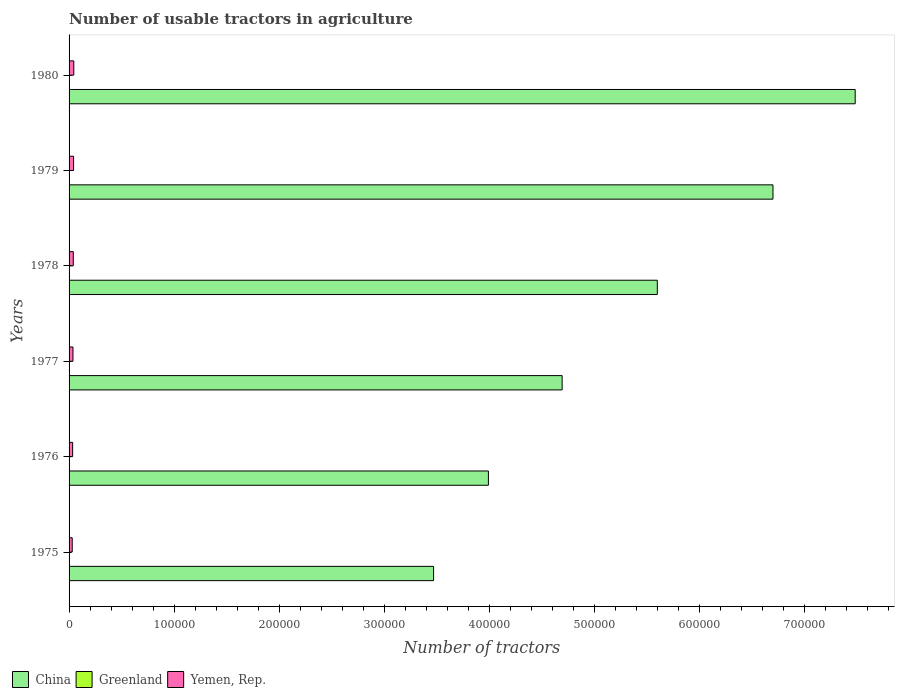How many different coloured bars are there?
Your answer should be very brief. 3. How many groups of bars are there?
Your answer should be compact. 6. How many bars are there on the 5th tick from the top?
Give a very brief answer. 3. What is the label of the 2nd group of bars from the top?
Your response must be concise. 1979. In how many cases, is the number of bars for a given year not equal to the number of legend labels?
Offer a terse response. 0. What is the number of usable tractors in agriculture in Greenland in 1980?
Your answer should be compact. 76. Across all years, what is the maximum number of usable tractors in agriculture in China?
Offer a terse response. 7.48e+05. Across all years, what is the minimum number of usable tractors in agriculture in China?
Make the answer very short. 3.47e+05. In which year was the number of usable tractors in agriculture in Yemen, Rep. maximum?
Your answer should be very brief. 1980. In which year was the number of usable tractors in agriculture in Greenland minimum?
Make the answer very short. 1975. What is the total number of usable tractors in agriculture in Yemen, Rep. in the graph?
Make the answer very short. 2.29e+04. What is the difference between the number of usable tractors in agriculture in Yemen, Rep. in 1975 and that in 1977?
Ensure brevity in your answer.  -700. What is the difference between the number of usable tractors in agriculture in Greenland in 1979 and the number of usable tractors in agriculture in Yemen, Rep. in 1977?
Give a very brief answer. -3626. In the year 1978, what is the difference between the number of usable tractors in agriculture in China and number of usable tractors in agriculture in Greenland?
Keep it short and to the point. 5.60e+05. In how many years, is the number of usable tractors in agriculture in Yemen, Rep. greater than 500000 ?
Offer a terse response. 0. What is the ratio of the number of usable tractors in agriculture in Greenland in 1975 to that in 1977?
Keep it short and to the point. 0.94. Is the difference between the number of usable tractors in agriculture in China in 1975 and 1976 greater than the difference between the number of usable tractors in agriculture in Greenland in 1975 and 1976?
Offer a very short reply. No. What is the difference between the highest and the lowest number of usable tractors in agriculture in China?
Your response must be concise. 4.01e+05. In how many years, is the number of usable tractors in agriculture in Greenland greater than the average number of usable tractors in agriculture in Greenland taken over all years?
Your response must be concise. 3. Is the sum of the number of usable tractors in agriculture in Greenland in 1975 and 1976 greater than the maximum number of usable tractors in agriculture in China across all years?
Provide a short and direct response. No. What does the 2nd bar from the top in 1978 represents?
Provide a succinct answer. Greenland. What does the 1st bar from the bottom in 1978 represents?
Your response must be concise. China. Is it the case that in every year, the sum of the number of usable tractors in agriculture in China and number of usable tractors in agriculture in Greenland is greater than the number of usable tractors in agriculture in Yemen, Rep.?
Your answer should be very brief. Yes. How many bars are there?
Provide a short and direct response. 18. Are all the bars in the graph horizontal?
Give a very brief answer. Yes. Are the values on the major ticks of X-axis written in scientific E-notation?
Your response must be concise. No. Does the graph contain any zero values?
Your response must be concise. No. Where does the legend appear in the graph?
Keep it short and to the point. Bottom left. What is the title of the graph?
Ensure brevity in your answer.  Number of usable tractors in agriculture. What is the label or title of the X-axis?
Provide a short and direct response. Number of tractors. What is the Number of tractors in China in 1975?
Your answer should be very brief. 3.47e+05. What is the Number of tractors of Greenland in 1975?
Offer a terse response. 66. What is the Number of tractors in Yemen, Rep. in 1975?
Ensure brevity in your answer.  3000. What is the Number of tractors of China in 1976?
Your answer should be compact. 3.99e+05. What is the Number of tractors of Greenland in 1976?
Provide a succinct answer. 68. What is the Number of tractors of Yemen, Rep. in 1976?
Your answer should be very brief. 3400. What is the Number of tractors in China in 1977?
Make the answer very short. 4.69e+05. What is the Number of tractors of Yemen, Rep. in 1977?
Keep it short and to the point. 3700. What is the Number of tractors of China in 1978?
Provide a succinct answer. 5.60e+05. What is the Number of tractors in Yemen, Rep. in 1978?
Provide a short and direct response. 4000. What is the Number of tractors in China in 1979?
Your response must be concise. 6.70e+05. What is the Number of tractors in Greenland in 1979?
Your response must be concise. 74. What is the Number of tractors in Yemen, Rep. in 1979?
Give a very brief answer. 4300. What is the Number of tractors of China in 1980?
Keep it short and to the point. 7.48e+05. What is the Number of tractors of Greenland in 1980?
Your answer should be very brief. 76. What is the Number of tractors of Yemen, Rep. in 1980?
Provide a succinct answer. 4500. Across all years, what is the maximum Number of tractors in China?
Ensure brevity in your answer.  7.48e+05. Across all years, what is the maximum Number of tractors in Greenland?
Provide a short and direct response. 76. Across all years, what is the maximum Number of tractors in Yemen, Rep.?
Offer a terse response. 4500. Across all years, what is the minimum Number of tractors in China?
Keep it short and to the point. 3.47e+05. Across all years, what is the minimum Number of tractors of Greenland?
Offer a very short reply. 66. Across all years, what is the minimum Number of tractors of Yemen, Rep.?
Make the answer very short. 3000. What is the total Number of tractors of China in the graph?
Offer a terse response. 3.19e+06. What is the total Number of tractors of Greenland in the graph?
Your response must be concise. 426. What is the total Number of tractors of Yemen, Rep. in the graph?
Your answer should be compact. 2.29e+04. What is the difference between the Number of tractors in China in 1975 and that in 1976?
Keep it short and to the point. -5.22e+04. What is the difference between the Number of tractors of Greenland in 1975 and that in 1976?
Provide a short and direct response. -2. What is the difference between the Number of tractors of Yemen, Rep. in 1975 and that in 1976?
Your answer should be compact. -400. What is the difference between the Number of tractors of China in 1975 and that in 1977?
Offer a very short reply. -1.22e+05. What is the difference between the Number of tractors of Greenland in 1975 and that in 1977?
Your response must be concise. -4. What is the difference between the Number of tractors in Yemen, Rep. in 1975 and that in 1977?
Provide a succinct answer. -700. What is the difference between the Number of tractors in China in 1975 and that in 1978?
Offer a very short reply. -2.13e+05. What is the difference between the Number of tractors of Greenland in 1975 and that in 1978?
Your answer should be very brief. -6. What is the difference between the Number of tractors of Yemen, Rep. in 1975 and that in 1978?
Ensure brevity in your answer.  -1000. What is the difference between the Number of tractors of China in 1975 and that in 1979?
Offer a very short reply. -3.23e+05. What is the difference between the Number of tractors in Greenland in 1975 and that in 1979?
Provide a succinct answer. -8. What is the difference between the Number of tractors in Yemen, Rep. in 1975 and that in 1979?
Provide a short and direct response. -1300. What is the difference between the Number of tractors of China in 1975 and that in 1980?
Keep it short and to the point. -4.01e+05. What is the difference between the Number of tractors of Greenland in 1975 and that in 1980?
Your response must be concise. -10. What is the difference between the Number of tractors in Yemen, Rep. in 1975 and that in 1980?
Make the answer very short. -1500. What is the difference between the Number of tractors of China in 1976 and that in 1977?
Your response must be concise. -7.02e+04. What is the difference between the Number of tractors in Greenland in 1976 and that in 1977?
Your response must be concise. -2. What is the difference between the Number of tractors of Yemen, Rep. in 1976 and that in 1977?
Ensure brevity in your answer.  -300. What is the difference between the Number of tractors in China in 1976 and that in 1978?
Make the answer very short. -1.61e+05. What is the difference between the Number of tractors in Greenland in 1976 and that in 1978?
Make the answer very short. -4. What is the difference between the Number of tractors in Yemen, Rep. in 1976 and that in 1978?
Ensure brevity in your answer.  -600. What is the difference between the Number of tractors of China in 1976 and that in 1979?
Provide a short and direct response. -2.71e+05. What is the difference between the Number of tractors of Greenland in 1976 and that in 1979?
Your answer should be very brief. -6. What is the difference between the Number of tractors in Yemen, Rep. in 1976 and that in 1979?
Your answer should be compact. -900. What is the difference between the Number of tractors of China in 1976 and that in 1980?
Keep it short and to the point. -3.49e+05. What is the difference between the Number of tractors of Greenland in 1976 and that in 1980?
Your answer should be compact. -8. What is the difference between the Number of tractors in Yemen, Rep. in 1976 and that in 1980?
Your answer should be very brief. -1100. What is the difference between the Number of tractors of China in 1977 and that in 1978?
Offer a very short reply. -9.05e+04. What is the difference between the Number of tractors in Greenland in 1977 and that in 1978?
Offer a terse response. -2. What is the difference between the Number of tractors of Yemen, Rep. in 1977 and that in 1978?
Your answer should be compact. -300. What is the difference between the Number of tractors of China in 1977 and that in 1979?
Offer a very short reply. -2.01e+05. What is the difference between the Number of tractors in Greenland in 1977 and that in 1979?
Your answer should be very brief. -4. What is the difference between the Number of tractors of Yemen, Rep. in 1977 and that in 1979?
Offer a terse response. -600. What is the difference between the Number of tractors of China in 1977 and that in 1980?
Your response must be concise. -2.79e+05. What is the difference between the Number of tractors in Yemen, Rep. in 1977 and that in 1980?
Keep it short and to the point. -800. What is the difference between the Number of tractors in China in 1978 and that in 1979?
Keep it short and to the point. -1.10e+05. What is the difference between the Number of tractors of Yemen, Rep. in 1978 and that in 1979?
Ensure brevity in your answer.  -300. What is the difference between the Number of tractors of China in 1978 and that in 1980?
Provide a succinct answer. -1.88e+05. What is the difference between the Number of tractors of Greenland in 1978 and that in 1980?
Give a very brief answer. -4. What is the difference between the Number of tractors of Yemen, Rep. in 1978 and that in 1980?
Your answer should be compact. -500. What is the difference between the Number of tractors of China in 1979 and that in 1980?
Offer a very short reply. -7.82e+04. What is the difference between the Number of tractors in Yemen, Rep. in 1979 and that in 1980?
Provide a succinct answer. -200. What is the difference between the Number of tractors of China in 1975 and the Number of tractors of Greenland in 1976?
Your response must be concise. 3.47e+05. What is the difference between the Number of tractors in China in 1975 and the Number of tractors in Yemen, Rep. in 1976?
Provide a short and direct response. 3.43e+05. What is the difference between the Number of tractors of Greenland in 1975 and the Number of tractors of Yemen, Rep. in 1976?
Provide a short and direct response. -3334. What is the difference between the Number of tractors of China in 1975 and the Number of tractors of Greenland in 1977?
Your answer should be compact. 3.47e+05. What is the difference between the Number of tractors of China in 1975 and the Number of tractors of Yemen, Rep. in 1977?
Your response must be concise. 3.43e+05. What is the difference between the Number of tractors of Greenland in 1975 and the Number of tractors of Yemen, Rep. in 1977?
Ensure brevity in your answer.  -3634. What is the difference between the Number of tractors in China in 1975 and the Number of tractors in Greenland in 1978?
Provide a succinct answer. 3.47e+05. What is the difference between the Number of tractors of China in 1975 and the Number of tractors of Yemen, Rep. in 1978?
Provide a succinct answer. 3.43e+05. What is the difference between the Number of tractors in Greenland in 1975 and the Number of tractors in Yemen, Rep. in 1978?
Keep it short and to the point. -3934. What is the difference between the Number of tractors in China in 1975 and the Number of tractors in Greenland in 1979?
Give a very brief answer. 3.47e+05. What is the difference between the Number of tractors of China in 1975 and the Number of tractors of Yemen, Rep. in 1979?
Your response must be concise. 3.42e+05. What is the difference between the Number of tractors of Greenland in 1975 and the Number of tractors of Yemen, Rep. in 1979?
Ensure brevity in your answer.  -4234. What is the difference between the Number of tractors in China in 1975 and the Number of tractors in Greenland in 1980?
Offer a terse response. 3.47e+05. What is the difference between the Number of tractors in China in 1975 and the Number of tractors in Yemen, Rep. in 1980?
Give a very brief answer. 3.42e+05. What is the difference between the Number of tractors in Greenland in 1975 and the Number of tractors in Yemen, Rep. in 1980?
Offer a very short reply. -4434. What is the difference between the Number of tractors in China in 1976 and the Number of tractors in Greenland in 1977?
Offer a very short reply. 3.99e+05. What is the difference between the Number of tractors in China in 1976 and the Number of tractors in Yemen, Rep. in 1977?
Make the answer very short. 3.95e+05. What is the difference between the Number of tractors of Greenland in 1976 and the Number of tractors of Yemen, Rep. in 1977?
Ensure brevity in your answer.  -3632. What is the difference between the Number of tractors in China in 1976 and the Number of tractors in Greenland in 1978?
Ensure brevity in your answer.  3.99e+05. What is the difference between the Number of tractors in China in 1976 and the Number of tractors in Yemen, Rep. in 1978?
Make the answer very short. 3.95e+05. What is the difference between the Number of tractors in Greenland in 1976 and the Number of tractors in Yemen, Rep. in 1978?
Make the answer very short. -3932. What is the difference between the Number of tractors of China in 1976 and the Number of tractors of Greenland in 1979?
Your answer should be compact. 3.99e+05. What is the difference between the Number of tractors of China in 1976 and the Number of tractors of Yemen, Rep. in 1979?
Make the answer very short. 3.95e+05. What is the difference between the Number of tractors in Greenland in 1976 and the Number of tractors in Yemen, Rep. in 1979?
Provide a succinct answer. -4232. What is the difference between the Number of tractors in China in 1976 and the Number of tractors in Greenland in 1980?
Keep it short and to the point. 3.99e+05. What is the difference between the Number of tractors in China in 1976 and the Number of tractors in Yemen, Rep. in 1980?
Your answer should be compact. 3.94e+05. What is the difference between the Number of tractors of Greenland in 1976 and the Number of tractors of Yemen, Rep. in 1980?
Your response must be concise. -4432. What is the difference between the Number of tractors in China in 1977 and the Number of tractors in Greenland in 1978?
Make the answer very short. 4.69e+05. What is the difference between the Number of tractors in China in 1977 and the Number of tractors in Yemen, Rep. in 1978?
Give a very brief answer. 4.65e+05. What is the difference between the Number of tractors of Greenland in 1977 and the Number of tractors of Yemen, Rep. in 1978?
Ensure brevity in your answer.  -3930. What is the difference between the Number of tractors of China in 1977 and the Number of tractors of Greenland in 1979?
Your response must be concise. 4.69e+05. What is the difference between the Number of tractors of China in 1977 and the Number of tractors of Yemen, Rep. in 1979?
Your answer should be compact. 4.65e+05. What is the difference between the Number of tractors of Greenland in 1977 and the Number of tractors of Yemen, Rep. in 1979?
Give a very brief answer. -4230. What is the difference between the Number of tractors of China in 1977 and the Number of tractors of Greenland in 1980?
Ensure brevity in your answer.  4.69e+05. What is the difference between the Number of tractors of China in 1977 and the Number of tractors of Yemen, Rep. in 1980?
Provide a succinct answer. 4.65e+05. What is the difference between the Number of tractors in Greenland in 1977 and the Number of tractors in Yemen, Rep. in 1980?
Your answer should be compact. -4430. What is the difference between the Number of tractors of China in 1978 and the Number of tractors of Greenland in 1979?
Your answer should be very brief. 5.60e+05. What is the difference between the Number of tractors in China in 1978 and the Number of tractors in Yemen, Rep. in 1979?
Your response must be concise. 5.55e+05. What is the difference between the Number of tractors of Greenland in 1978 and the Number of tractors of Yemen, Rep. in 1979?
Your answer should be compact. -4228. What is the difference between the Number of tractors of China in 1978 and the Number of tractors of Greenland in 1980?
Offer a very short reply. 5.60e+05. What is the difference between the Number of tractors in China in 1978 and the Number of tractors in Yemen, Rep. in 1980?
Provide a succinct answer. 5.55e+05. What is the difference between the Number of tractors in Greenland in 1978 and the Number of tractors in Yemen, Rep. in 1980?
Your answer should be compact. -4428. What is the difference between the Number of tractors of China in 1979 and the Number of tractors of Greenland in 1980?
Keep it short and to the point. 6.70e+05. What is the difference between the Number of tractors in China in 1979 and the Number of tractors in Yemen, Rep. in 1980?
Offer a very short reply. 6.65e+05. What is the difference between the Number of tractors of Greenland in 1979 and the Number of tractors of Yemen, Rep. in 1980?
Your answer should be compact. -4426. What is the average Number of tractors in China per year?
Your response must be concise. 5.32e+05. What is the average Number of tractors in Greenland per year?
Provide a short and direct response. 71. What is the average Number of tractors of Yemen, Rep. per year?
Offer a very short reply. 3816.67. In the year 1975, what is the difference between the Number of tractors in China and Number of tractors in Greenland?
Your answer should be very brief. 3.47e+05. In the year 1975, what is the difference between the Number of tractors in China and Number of tractors in Yemen, Rep.?
Provide a short and direct response. 3.44e+05. In the year 1975, what is the difference between the Number of tractors of Greenland and Number of tractors of Yemen, Rep.?
Your answer should be compact. -2934. In the year 1976, what is the difference between the Number of tractors of China and Number of tractors of Greenland?
Offer a very short reply. 3.99e+05. In the year 1976, what is the difference between the Number of tractors in China and Number of tractors in Yemen, Rep.?
Offer a terse response. 3.96e+05. In the year 1976, what is the difference between the Number of tractors in Greenland and Number of tractors in Yemen, Rep.?
Make the answer very short. -3332. In the year 1977, what is the difference between the Number of tractors of China and Number of tractors of Greenland?
Keep it short and to the point. 4.69e+05. In the year 1977, what is the difference between the Number of tractors in China and Number of tractors in Yemen, Rep.?
Your answer should be compact. 4.65e+05. In the year 1977, what is the difference between the Number of tractors in Greenland and Number of tractors in Yemen, Rep.?
Your answer should be very brief. -3630. In the year 1978, what is the difference between the Number of tractors of China and Number of tractors of Greenland?
Provide a short and direct response. 5.60e+05. In the year 1978, what is the difference between the Number of tractors in China and Number of tractors in Yemen, Rep.?
Offer a terse response. 5.56e+05. In the year 1978, what is the difference between the Number of tractors of Greenland and Number of tractors of Yemen, Rep.?
Keep it short and to the point. -3928. In the year 1979, what is the difference between the Number of tractors in China and Number of tractors in Greenland?
Your response must be concise. 6.70e+05. In the year 1979, what is the difference between the Number of tractors in China and Number of tractors in Yemen, Rep.?
Give a very brief answer. 6.65e+05. In the year 1979, what is the difference between the Number of tractors of Greenland and Number of tractors of Yemen, Rep.?
Offer a terse response. -4226. In the year 1980, what is the difference between the Number of tractors in China and Number of tractors in Greenland?
Keep it short and to the point. 7.48e+05. In the year 1980, what is the difference between the Number of tractors in China and Number of tractors in Yemen, Rep.?
Make the answer very short. 7.43e+05. In the year 1980, what is the difference between the Number of tractors in Greenland and Number of tractors in Yemen, Rep.?
Your answer should be very brief. -4424. What is the ratio of the Number of tractors of China in 1975 to that in 1976?
Make the answer very short. 0.87. What is the ratio of the Number of tractors in Greenland in 1975 to that in 1976?
Give a very brief answer. 0.97. What is the ratio of the Number of tractors in Yemen, Rep. in 1975 to that in 1976?
Your answer should be compact. 0.88. What is the ratio of the Number of tractors of China in 1975 to that in 1977?
Your answer should be very brief. 0.74. What is the ratio of the Number of tractors of Greenland in 1975 to that in 1977?
Your response must be concise. 0.94. What is the ratio of the Number of tractors of Yemen, Rep. in 1975 to that in 1977?
Your answer should be compact. 0.81. What is the ratio of the Number of tractors of China in 1975 to that in 1978?
Ensure brevity in your answer.  0.62. What is the ratio of the Number of tractors in Greenland in 1975 to that in 1978?
Give a very brief answer. 0.92. What is the ratio of the Number of tractors in Yemen, Rep. in 1975 to that in 1978?
Make the answer very short. 0.75. What is the ratio of the Number of tractors in China in 1975 to that in 1979?
Offer a very short reply. 0.52. What is the ratio of the Number of tractors in Greenland in 1975 to that in 1979?
Your answer should be very brief. 0.89. What is the ratio of the Number of tractors of Yemen, Rep. in 1975 to that in 1979?
Your answer should be compact. 0.7. What is the ratio of the Number of tractors of China in 1975 to that in 1980?
Offer a very short reply. 0.46. What is the ratio of the Number of tractors of Greenland in 1975 to that in 1980?
Provide a short and direct response. 0.87. What is the ratio of the Number of tractors in China in 1976 to that in 1977?
Your response must be concise. 0.85. What is the ratio of the Number of tractors in Greenland in 1976 to that in 1977?
Your response must be concise. 0.97. What is the ratio of the Number of tractors of Yemen, Rep. in 1976 to that in 1977?
Provide a succinct answer. 0.92. What is the ratio of the Number of tractors in China in 1976 to that in 1978?
Offer a very short reply. 0.71. What is the ratio of the Number of tractors of Greenland in 1976 to that in 1978?
Your response must be concise. 0.94. What is the ratio of the Number of tractors of Yemen, Rep. in 1976 to that in 1978?
Give a very brief answer. 0.85. What is the ratio of the Number of tractors in China in 1976 to that in 1979?
Your response must be concise. 0.6. What is the ratio of the Number of tractors in Greenland in 1976 to that in 1979?
Offer a terse response. 0.92. What is the ratio of the Number of tractors of Yemen, Rep. in 1976 to that in 1979?
Provide a short and direct response. 0.79. What is the ratio of the Number of tractors in China in 1976 to that in 1980?
Offer a terse response. 0.53. What is the ratio of the Number of tractors in Greenland in 1976 to that in 1980?
Offer a terse response. 0.89. What is the ratio of the Number of tractors in Yemen, Rep. in 1976 to that in 1980?
Give a very brief answer. 0.76. What is the ratio of the Number of tractors in China in 1977 to that in 1978?
Provide a succinct answer. 0.84. What is the ratio of the Number of tractors of Greenland in 1977 to that in 1978?
Your answer should be very brief. 0.97. What is the ratio of the Number of tractors in Yemen, Rep. in 1977 to that in 1978?
Offer a terse response. 0.93. What is the ratio of the Number of tractors of China in 1977 to that in 1979?
Provide a short and direct response. 0.7. What is the ratio of the Number of tractors in Greenland in 1977 to that in 1979?
Your answer should be compact. 0.95. What is the ratio of the Number of tractors of Yemen, Rep. in 1977 to that in 1979?
Offer a terse response. 0.86. What is the ratio of the Number of tractors of China in 1977 to that in 1980?
Give a very brief answer. 0.63. What is the ratio of the Number of tractors in Greenland in 1977 to that in 1980?
Your answer should be compact. 0.92. What is the ratio of the Number of tractors of Yemen, Rep. in 1977 to that in 1980?
Ensure brevity in your answer.  0.82. What is the ratio of the Number of tractors of China in 1978 to that in 1979?
Ensure brevity in your answer.  0.84. What is the ratio of the Number of tractors of Yemen, Rep. in 1978 to that in 1979?
Your answer should be very brief. 0.93. What is the ratio of the Number of tractors of China in 1978 to that in 1980?
Your answer should be compact. 0.75. What is the ratio of the Number of tractors in Yemen, Rep. in 1978 to that in 1980?
Offer a very short reply. 0.89. What is the ratio of the Number of tractors of China in 1979 to that in 1980?
Offer a terse response. 0.9. What is the ratio of the Number of tractors in Greenland in 1979 to that in 1980?
Make the answer very short. 0.97. What is the ratio of the Number of tractors in Yemen, Rep. in 1979 to that in 1980?
Your answer should be compact. 0.96. What is the difference between the highest and the second highest Number of tractors in China?
Your answer should be very brief. 7.82e+04. What is the difference between the highest and the lowest Number of tractors in China?
Your answer should be compact. 4.01e+05. What is the difference between the highest and the lowest Number of tractors in Greenland?
Provide a succinct answer. 10. What is the difference between the highest and the lowest Number of tractors of Yemen, Rep.?
Offer a very short reply. 1500. 